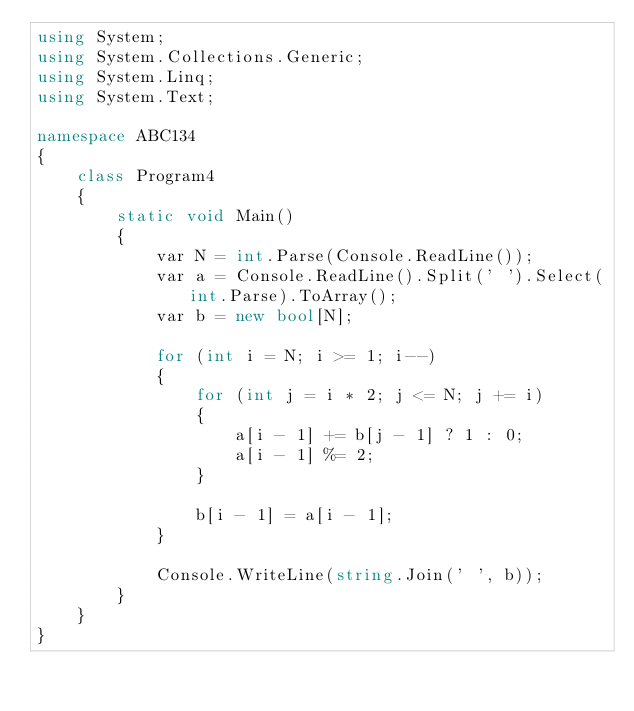<code> <loc_0><loc_0><loc_500><loc_500><_C#_>using System;
using System.Collections.Generic;
using System.Linq;
using System.Text;

namespace ABC134
{
    class Program4
    {
        static void Main()
        {
            var N = int.Parse(Console.ReadLine());
            var a = Console.ReadLine().Split(' ').Select(int.Parse).ToArray();
            var b = new bool[N];

            for (int i = N; i >= 1; i--)
            {
                for (int j = i * 2; j <= N; j += i)
                {
                    a[i - 1] += b[j - 1] ? 1 : 0;
                    a[i - 1] %= 2;
                }

                b[i - 1] = a[i - 1];
            }

            Console.WriteLine(string.Join(' ', b));
        }
    }
}
</code> 